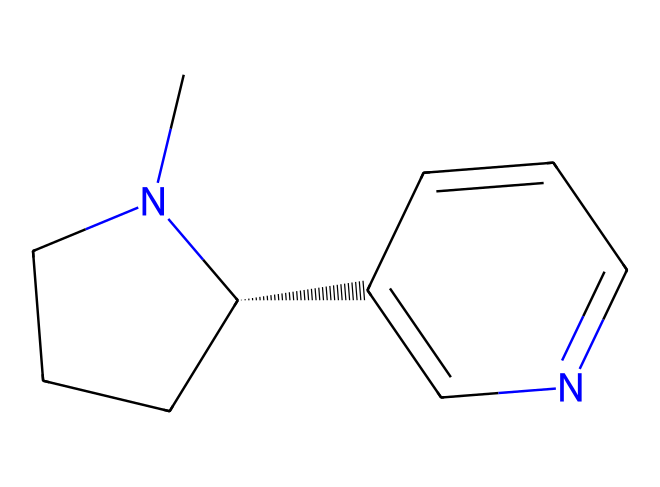What is the molecular formula of nicotine? The SMILES notation indicates the presence of carbons (C), hydrogens (H), and nitrogen (N). By interpreting the structure, we can derive the molecular formula C10H14N2.
Answer: C10H14N2 How many nitrogen atoms are in this molecule? Analyzing the SMILES representation, we see two nitrogen atoms denoted by 'N' in the structure.
Answer: 2 What type of chemical structure does nicotine have? The SMILES indicates that nicotine has a ring structure with substituents. It is characterized as a bicyclic structure, common in alkaloids.
Answer: bicyclic Which part of this molecule is responsible for its psychoactive properties? The presence of specific nitrogen atoms in the bicyclic structure contributes to the psychoactive effects of nicotine by acting on neurotransmitter receptors.
Answer: nitrogen How many rings are there in the nicotine structure? The structure shows two interconnected rings due to the connections made in the SMILES. Counted, there are two distinct rings in the structure.
Answer: 2 What is the significance of the stereochemistry in this alkaloid? The presence of the '@' symbol in the SMILES indicates a chiral center, which is crucial for the biological activity of nicotine as it affects how the molecule interacts with receptors in the body.
Answer: chiral center What functional group is present in nicotine? The nitrogen atoms suggest the presence of amine functional groups, which are characteristic of alkaloids.
Answer: amine 